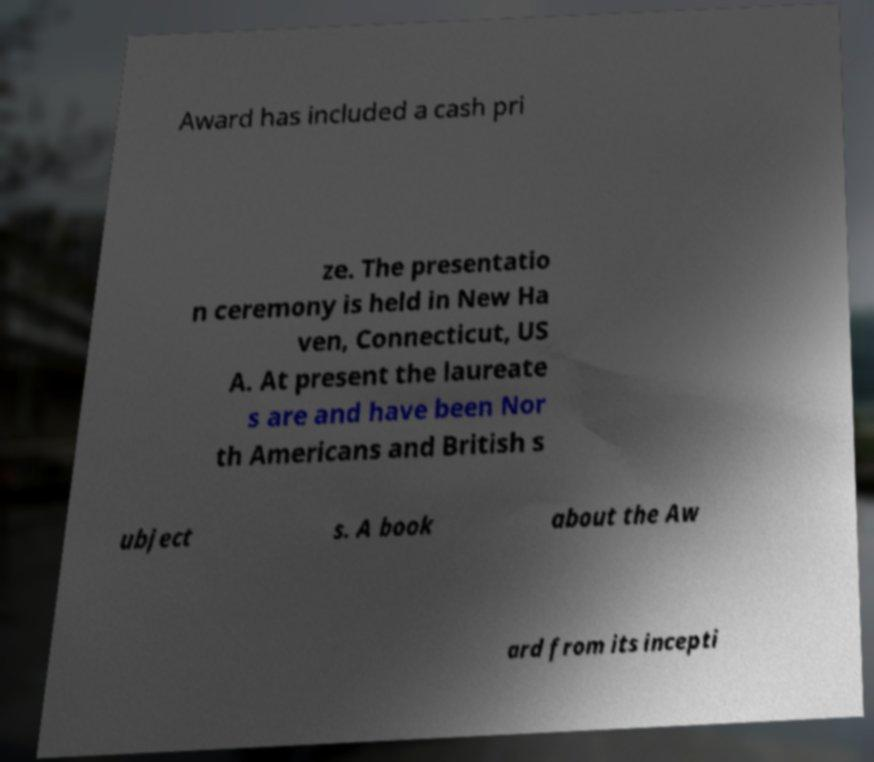There's text embedded in this image that I need extracted. Can you transcribe it verbatim? Award has included a cash pri ze. The presentatio n ceremony is held in New Ha ven, Connecticut, US A. At present the laureate s are and have been Nor th Americans and British s ubject s. A book about the Aw ard from its incepti 